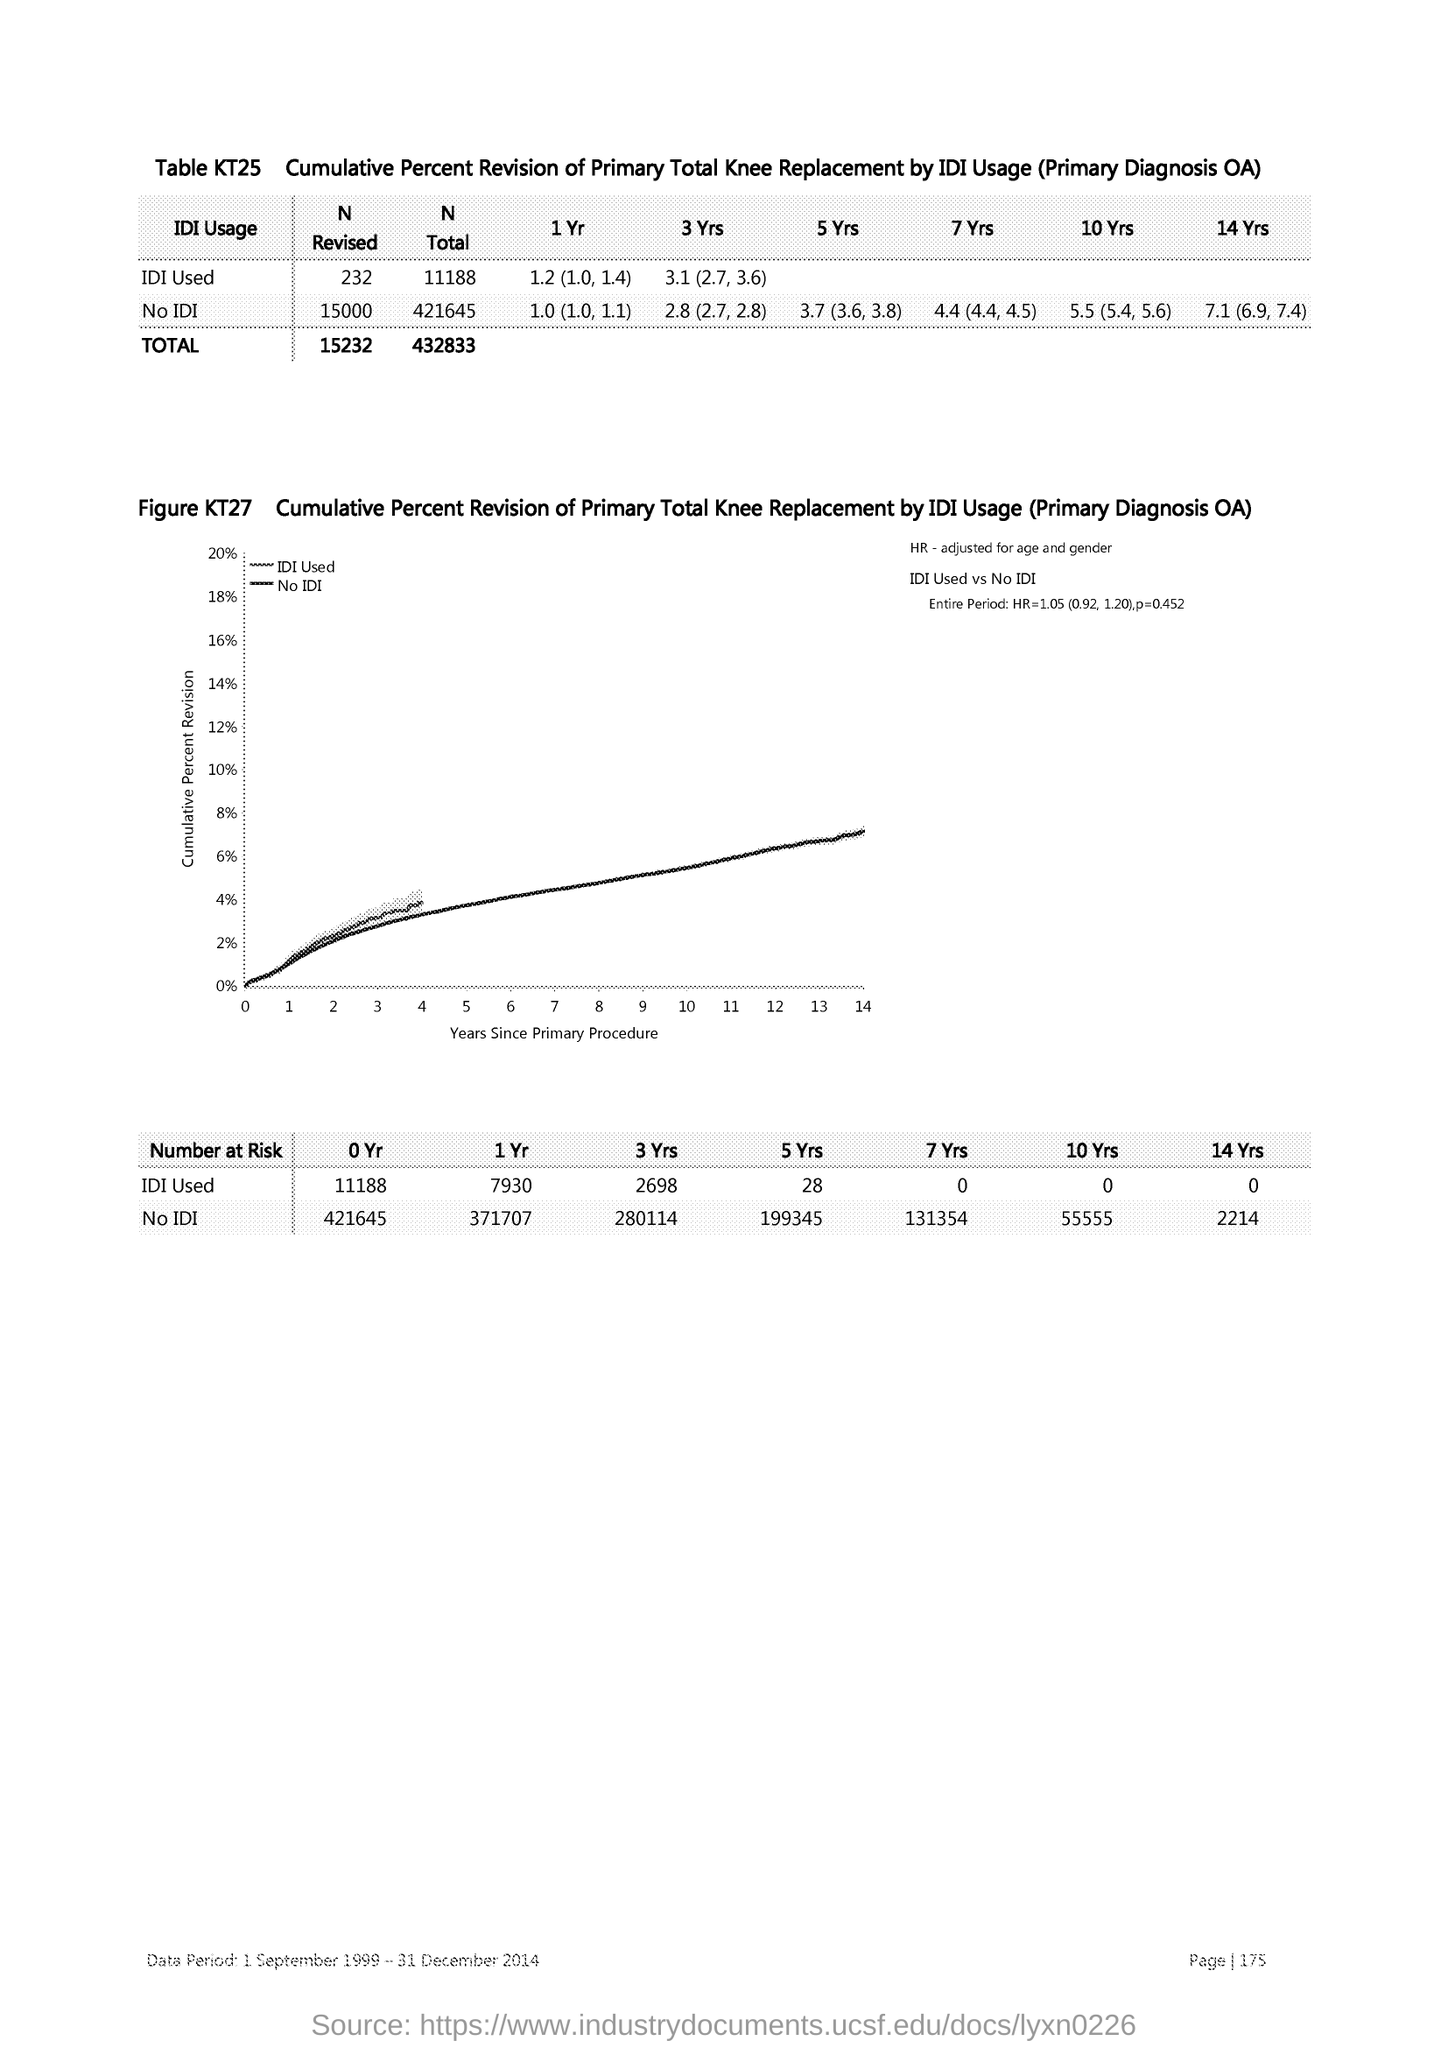List a handful of essential elements in this visual. The y-axis in the graph displays the cumulative percentage revision of the input data. The x-axis displays the years since the primary procedure was performed, providing a reference point for tracking the progression of disease. 